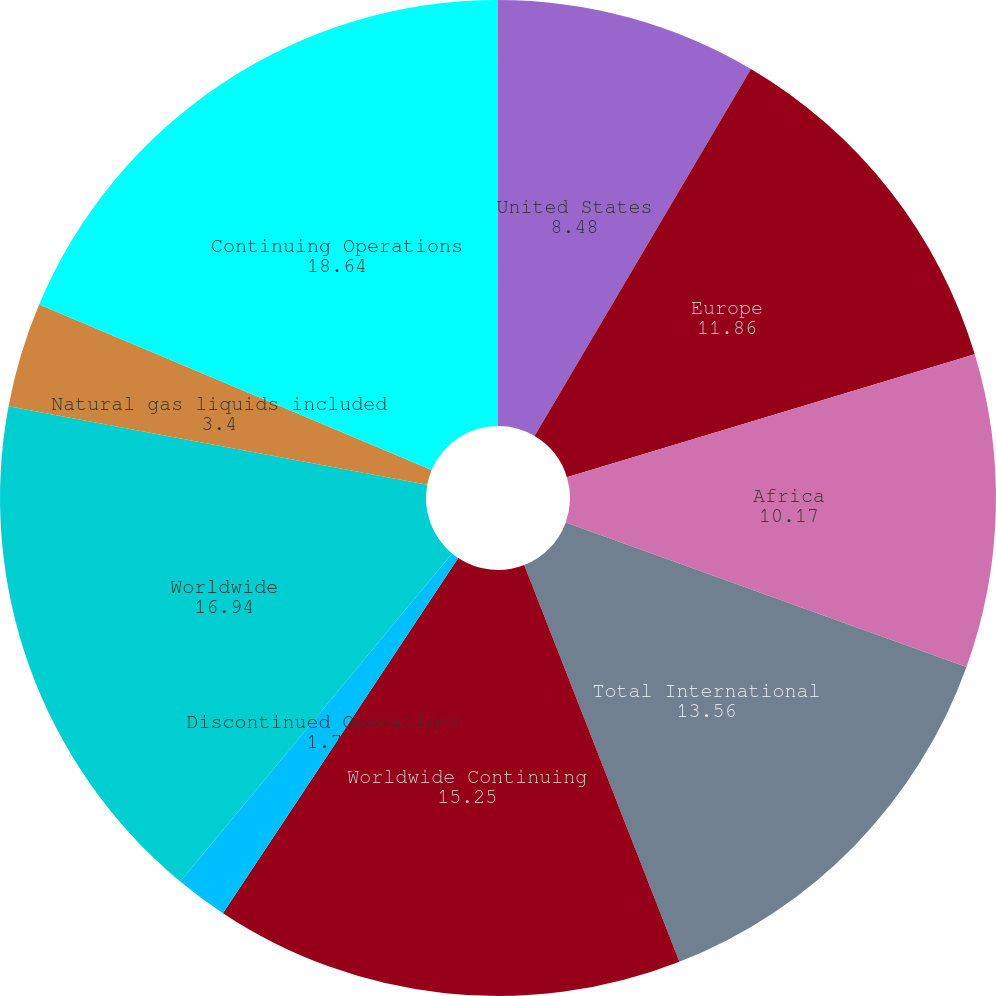Convert chart to OTSL. <chart><loc_0><loc_0><loc_500><loc_500><pie_chart><fcel>United States<fcel>Europe<fcel>Africa<fcel>Total International<fcel>Worldwide Continuing<fcel>Discontinued Operations<fcel>Worldwide<fcel>Natural gas liquids included<fcel>Continuing Operations<fcel>Africa (e)<nl><fcel>8.48%<fcel>11.86%<fcel>10.17%<fcel>13.56%<fcel>15.25%<fcel>1.7%<fcel>16.94%<fcel>3.4%<fcel>18.64%<fcel>0.01%<nl></chart> 